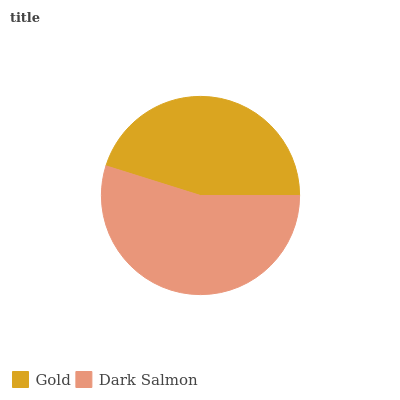Is Gold the minimum?
Answer yes or no. Yes. Is Dark Salmon the maximum?
Answer yes or no. Yes. Is Dark Salmon the minimum?
Answer yes or no. No. Is Dark Salmon greater than Gold?
Answer yes or no. Yes. Is Gold less than Dark Salmon?
Answer yes or no. Yes. Is Gold greater than Dark Salmon?
Answer yes or no. No. Is Dark Salmon less than Gold?
Answer yes or no. No. Is Dark Salmon the high median?
Answer yes or no. Yes. Is Gold the low median?
Answer yes or no. Yes. Is Gold the high median?
Answer yes or no. No. Is Dark Salmon the low median?
Answer yes or no. No. 